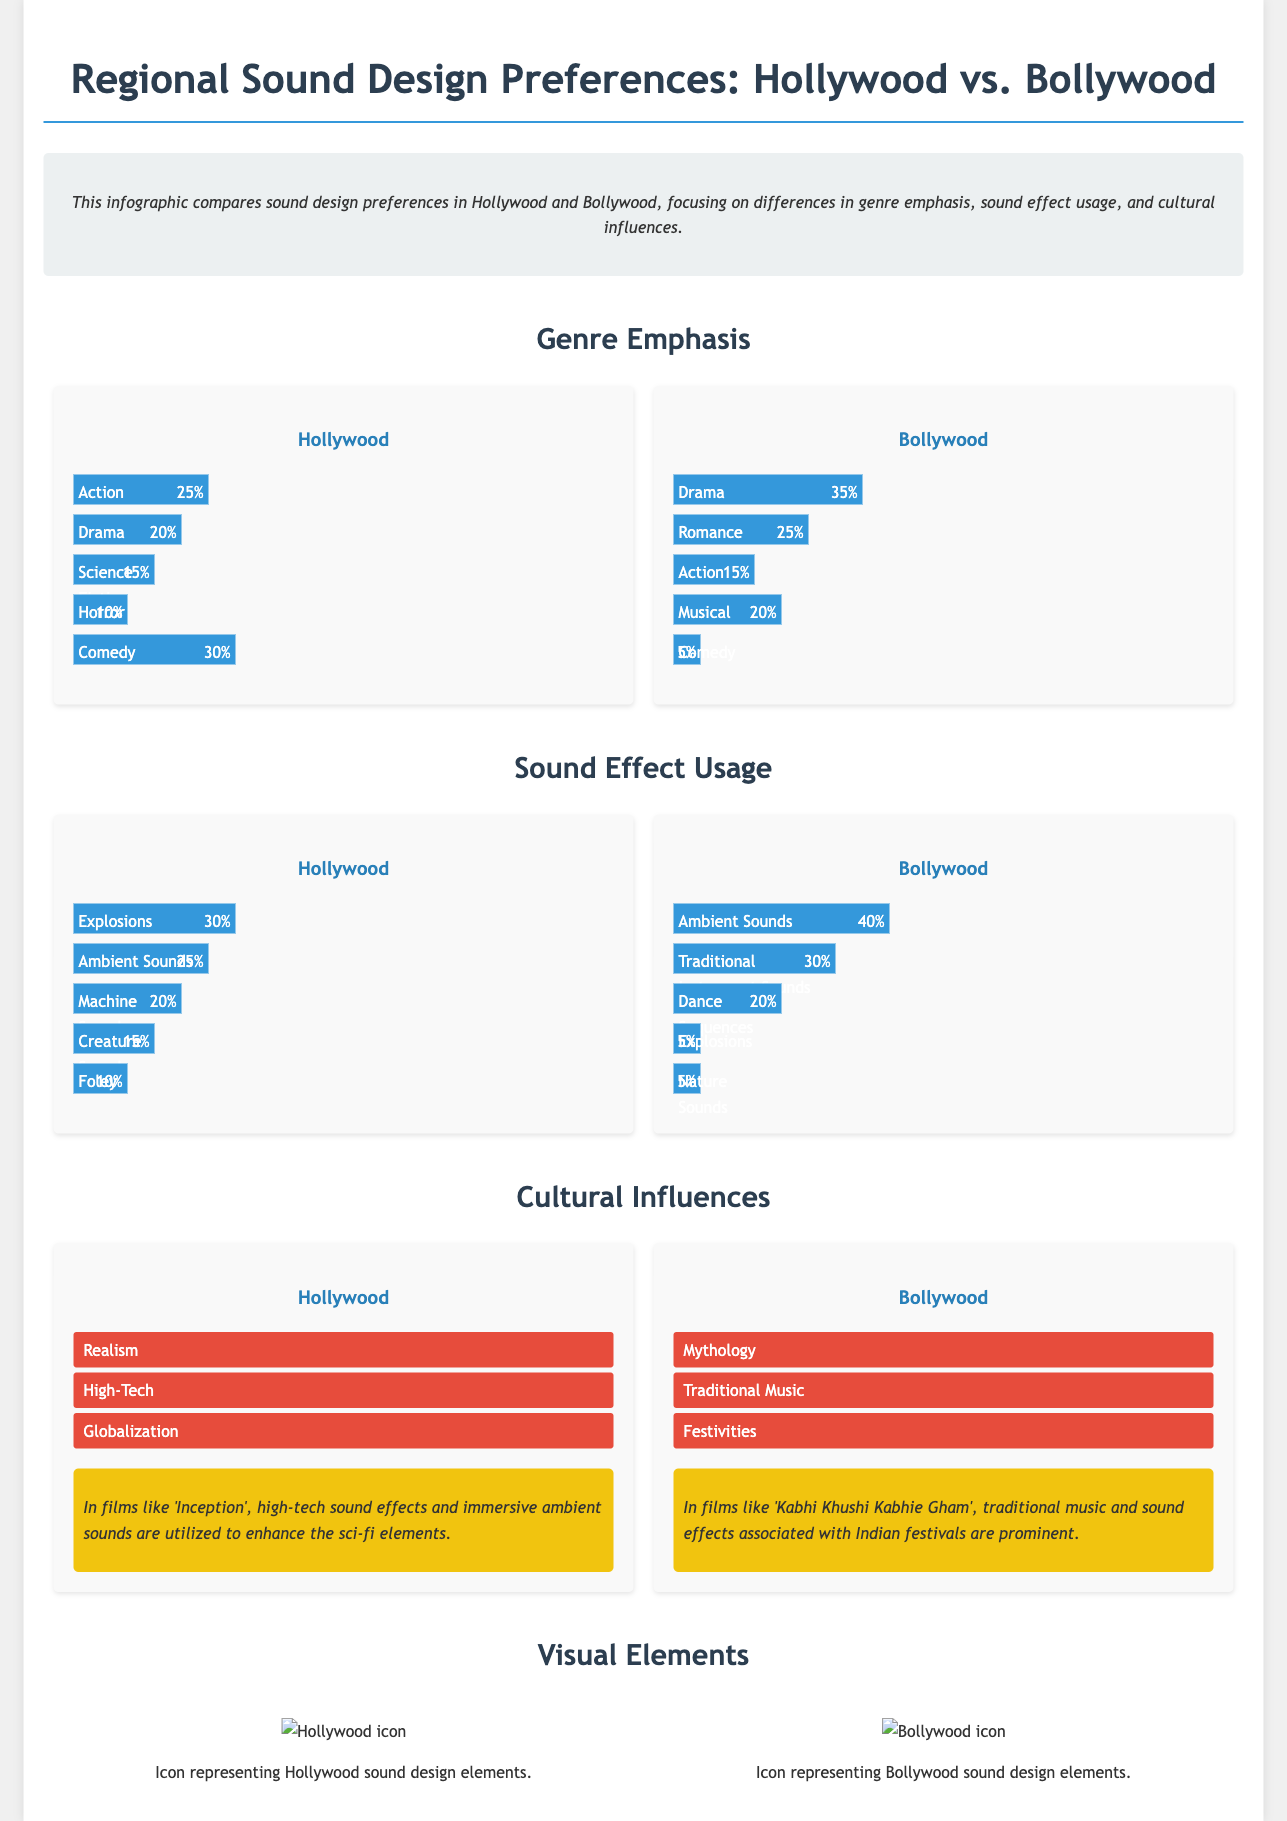what genre has the highest emphasis in Bollywood? The genre with the highest emphasis in Bollywood is Drama, which accounts for 35%.
Answer: Drama what percentage of sound effects in Hollywood are attributed to Explosions? In Hollywood, 30% of sound effects are attributed to Explosions.
Answer: 30% what are the top three cultural influences in Bollywood? The top three cultural influences in Bollywood are Mythology, Traditional Music, and Festivities.
Answer: Mythology, Traditional Music, Festivities how much emphasis is placed on Comedy in Hollywood compared to Bollywood? Hollywood has 30% emphasis on Comedy while Bollywood has only 5%, showing a significant difference in genre emphasis.
Answer: 30% vs. 5% which sound effect is most utilized in Bollywood? The most utilized sound effect in Bollywood is Ambient Sounds, which accounts for 40%.
Answer: Ambient Sounds what is the primary genre in Hollywood films? The primary genre in Hollywood films is Action, with 25% emphasis.
Answer: Action what percentage of Bollywood sound effects are used for Dance Sequences? In Bollywood, 20% of sound effects are attributed to Dance Sequences.
Answer: 20% which film example highlights high-tech sound design in Hollywood? The film example that highlights high-tech sound design in Hollywood is 'Inception'.
Answer: Inception what cultural influence is emphasized in Hollywood sound design? The emphasized cultural influence in Hollywood sound design is Realism.
Answer: Realism 